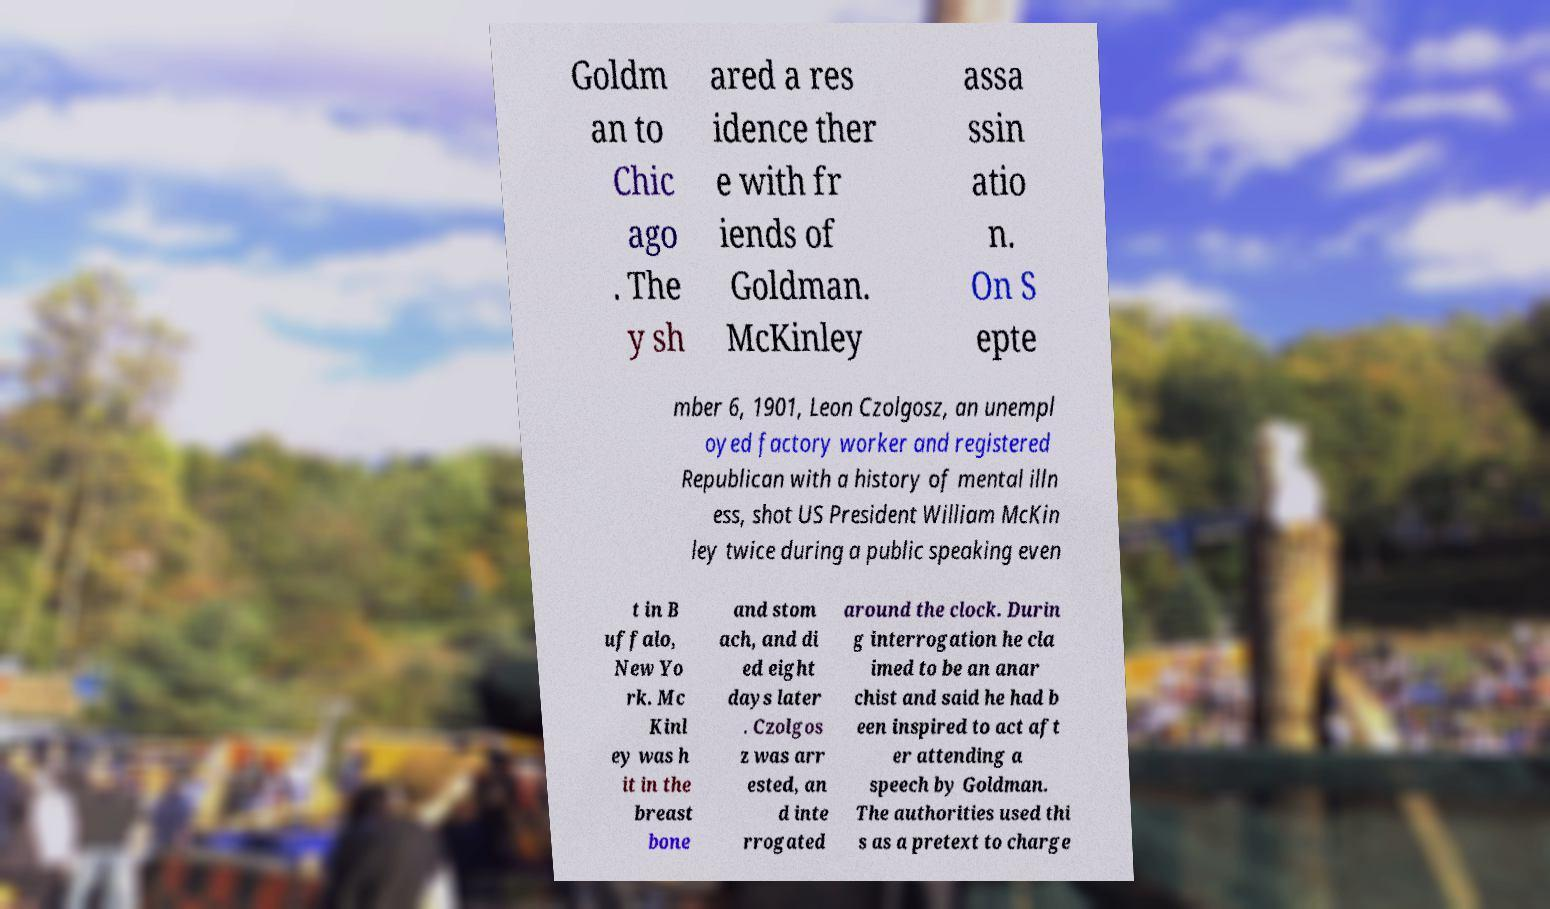I need the written content from this picture converted into text. Can you do that? Goldm an to Chic ago . The y sh ared a res idence ther e with fr iends of Goldman. McKinley assa ssin atio n. On S epte mber 6, 1901, Leon Czolgosz, an unempl oyed factory worker and registered Republican with a history of mental illn ess, shot US President William McKin ley twice during a public speaking even t in B uffalo, New Yo rk. Mc Kinl ey was h it in the breast bone and stom ach, and di ed eight days later . Czolgos z was arr ested, an d inte rrogated around the clock. Durin g interrogation he cla imed to be an anar chist and said he had b een inspired to act aft er attending a speech by Goldman. The authorities used thi s as a pretext to charge 